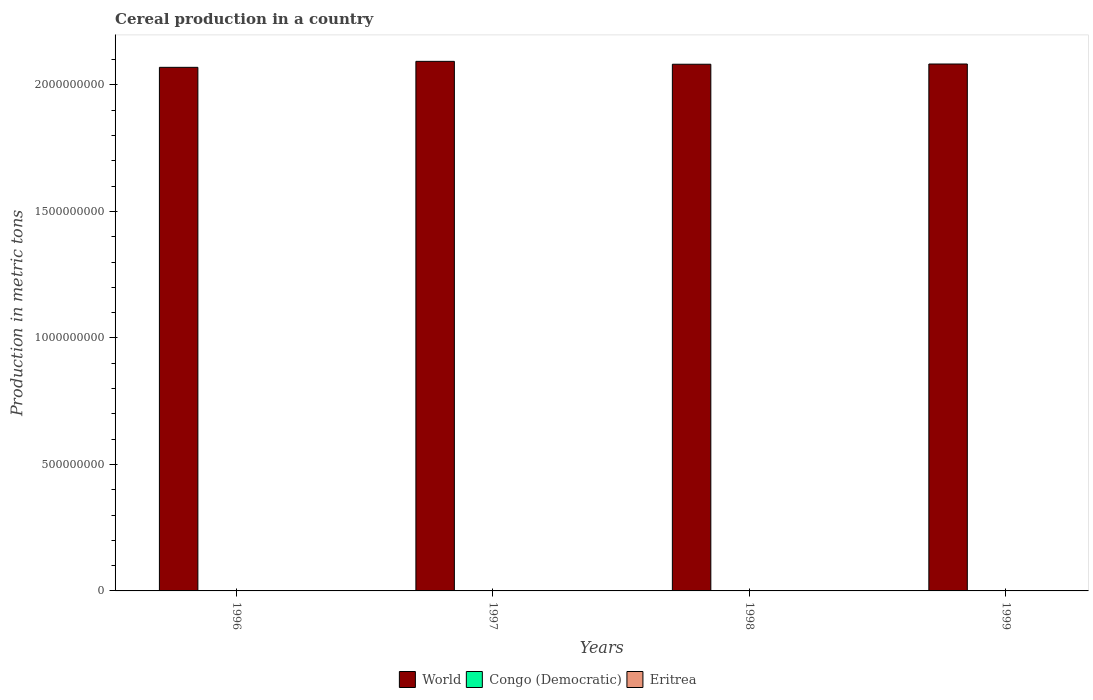How many different coloured bars are there?
Provide a succinct answer. 3. In how many cases, is the number of bars for a given year not equal to the number of legend labels?
Give a very brief answer. 0. What is the total cereal production in World in 1999?
Provide a succinct answer. 2.08e+09. Across all years, what is the maximum total cereal production in Eritrea?
Your answer should be compact. 4.58e+05. Across all years, what is the minimum total cereal production in Eritrea?
Provide a succinct answer. 8.54e+04. In which year was the total cereal production in World maximum?
Offer a very short reply. 1997. In which year was the total cereal production in World minimum?
Provide a short and direct response. 1996. What is the total total cereal production in Eritrea in the graph?
Provide a succinct answer. 9.61e+05. What is the difference between the total cereal production in Eritrea in 1996 and that in 1999?
Your answer should be compact. -2.33e+05. What is the difference between the total cereal production in Congo (Democratic) in 1998 and the total cereal production in World in 1999?
Offer a very short reply. -2.08e+09. What is the average total cereal production in World per year?
Make the answer very short. 2.08e+09. In the year 1997, what is the difference between the total cereal production in Eritrea and total cereal production in World?
Provide a short and direct response. -2.09e+09. What is the ratio of the total cereal production in World in 1997 to that in 1998?
Your response must be concise. 1.01. Is the total cereal production in World in 1996 less than that in 1998?
Your answer should be compact. Yes. Is the difference between the total cereal production in Eritrea in 1997 and 1999 greater than the difference between the total cereal production in World in 1997 and 1999?
Your response must be concise. No. What is the difference between the highest and the second highest total cereal production in Eritrea?
Offer a very short reply. 1.39e+05. What is the difference between the highest and the lowest total cereal production in Congo (Democratic)?
Keep it short and to the point. 8.96e+04. In how many years, is the total cereal production in Congo (Democratic) greater than the average total cereal production in Congo (Democratic) taken over all years?
Keep it short and to the point. 2. What does the 2nd bar from the left in 1999 represents?
Keep it short and to the point. Congo (Democratic). What does the 2nd bar from the right in 1996 represents?
Your answer should be compact. Congo (Democratic). Are all the bars in the graph horizontal?
Keep it short and to the point. No. How many years are there in the graph?
Ensure brevity in your answer.  4. Are the values on the major ticks of Y-axis written in scientific E-notation?
Your response must be concise. No. How many legend labels are there?
Provide a succinct answer. 3. What is the title of the graph?
Make the answer very short. Cereal production in a country. Does "Azerbaijan" appear as one of the legend labels in the graph?
Offer a terse response. No. What is the label or title of the X-axis?
Make the answer very short. Years. What is the label or title of the Y-axis?
Offer a very short reply. Production in metric tons. What is the Production in metric tons of World in 1996?
Offer a very short reply. 2.07e+09. What is the Production in metric tons in Congo (Democratic) in 1996?
Offer a terse response. 1.56e+06. What is the Production in metric tons of Eritrea in 1996?
Offer a terse response. 8.54e+04. What is the Production in metric tons of World in 1997?
Make the answer very short. 2.09e+09. What is the Production in metric tons of Congo (Democratic) in 1997?
Give a very brief answer. 1.53e+06. What is the Production in metric tons of Eritrea in 1997?
Your answer should be compact. 9.94e+04. What is the Production in metric tons of World in 1998?
Offer a terse response. 2.08e+09. What is the Production in metric tons in Congo (Democratic) in 1998?
Offer a very short reply. 1.62e+06. What is the Production in metric tons of Eritrea in 1998?
Ensure brevity in your answer.  4.58e+05. What is the Production in metric tons of World in 1999?
Ensure brevity in your answer.  2.08e+09. What is the Production in metric tons in Congo (Democratic) in 1999?
Make the answer very short. 1.59e+06. What is the Production in metric tons in Eritrea in 1999?
Your answer should be compact. 3.19e+05. Across all years, what is the maximum Production in metric tons of World?
Give a very brief answer. 2.09e+09. Across all years, what is the maximum Production in metric tons in Congo (Democratic)?
Provide a short and direct response. 1.62e+06. Across all years, what is the maximum Production in metric tons of Eritrea?
Provide a succinct answer. 4.58e+05. Across all years, what is the minimum Production in metric tons in World?
Provide a short and direct response. 2.07e+09. Across all years, what is the minimum Production in metric tons of Congo (Democratic)?
Make the answer very short. 1.53e+06. Across all years, what is the minimum Production in metric tons of Eritrea?
Your answer should be compact. 8.54e+04. What is the total Production in metric tons of World in the graph?
Offer a very short reply. 8.33e+09. What is the total Production in metric tons of Congo (Democratic) in the graph?
Your response must be concise. 6.30e+06. What is the total Production in metric tons in Eritrea in the graph?
Provide a short and direct response. 9.61e+05. What is the difference between the Production in metric tons of World in 1996 and that in 1997?
Offer a terse response. -2.37e+07. What is the difference between the Production in metric tons in Congo (Democratic) in 1996 and that in 1997?
Make the answer very short. 2.49e+04. What is the difference between the Production in metric tons in Eritrea in 1996 and that in 1997?
Your response must be concise. -1.40e+04. What is the difference between the Production in metric tons in World in 1996 and that in 1998?
Keep it short and to the point. -1.22e+07. What is the difference between the Production in metric tons in Congo (Democratic) in 1996 and that in 1998?
Provide a short and direct response. -6.46e+04. What is the difference between the Production in metric tons of Eritrea in 1996 and that in 1998?
Your response must be concise. -3.72e+05. What is the difference between the Production in metric tons of World in 1996 and that in 1999?
Give a very brief answer. -1.32e+07. What is the difference between the Production in metric tons in Congo (Democratic) in 1996 and that in 1999?
Provide a short and direct response. -3.60e+04. What is the difference between the Production in metric tons of Eritrea in 1996 and that in 1999?
Your answer should be very brief. -2.33e+05. What is the difference between the Production in metric tons in World in 1997 and that in 1998?
Offer a terse response. 1.14e+07. What is the difference between the Production in metric tons in Congo (Democratic) in 1997 and that in 1998?
Provide a succinct answer. -8.96e+04. What is the difference between the Production in metric tons in Eritrea in 1997 and that in 1998?
Offer a terse response. -3.58e+05. What is the difference between the Production in metric tons in World in 1997 and that in 1999?
Offer a terse response. 1.05e+07. What is the difference between the Production in metric tons of Congo (Democratic) in 1997 and that in 1999?
Ensure brevity in your answer.  -6.10e+04. What is the difference between the Production in metric tons of Eritrea in 1997 and that in 1999?
Offer a terse response. -2.19e+05. What is the difference between the Production in metric tons of World in 1998 and that in 1999?
Your answer should be compact. -9.28e+05. What is the difference between the Production in metric tons in Congo (Democratic) in 1998 and that in 1999?
Offer a very short reply. 2.86e+04. What is the difference between the Production in metric tons in Eritrea in 1998 and that in 1999?
Your answer should be very brief. 1.39e+05. What is the difference between the Production in metric tons in World in 1996 and the Production in metric tons in Congo (Democratic) in 1997?
Provide a succinct answer. 2.07e+09. What is the difference between the Production in metric tons in World in 1996 and the Production in metric tons in Eritrea in 1997?
Offer a terse response. 2.07e+09. What is the difference between the Production in metric tons of Congo (Democratic) in 1996 and the Production in metric tons of Eritrea in 1997?
Offer a terse response. 1.46e+06. What is the difference between the Production in metric tons in World in 1996 and the Production in metric tons in Congo (Democratic) in 1998?
Provide a succinct answer. 2.07e+09. What is the difference between the Production in metric tons of World in 1996 and the Production in metric tons of Eritrea in 1998?
Ensure brevity in your answer.  2.07e+09. What is the difference between the Production in metric tons of Congo (Democratic) in 1996 and the Production in metric tons of Eritrea in 1998?
Provide a succinct answer. 1.10e+06. What is the difference between the Production in metric tons of World in 1996 and the Production in metric tons of Congo (Democratic) in 1999?
Keep it short and to the point. 2.07e+09. What is the difference between the Production in metric tons of World in 1996 and the Production in metric tons of Eritrea in 1999?
Your answer should be very brief. 2.07e+09. What is the difference between the Production in metric tons of Congo (Democratic) in 1996 and the Production in metric tons of Eritrea in 1999?
Your response must be concise. 1.24e+06. What is the difference between the Production in metric tons in World in 1997 and the Production in metric tons in Congo (Democratic) in 1998?
Your answer should be compact. 2.09e+09. What is the difference between the Production in metric tons in World in 1997 and the Production in metric tons in Eritrea in 1998?
Your response must be concise. 2.09e+09. What is the difference between the Production in metric tons of Congo (Democratic) in 1997 and the Production in metric tons of Eritrea in 1998?
Keep it short and to the point. 1.07e+06. What is the difference between the Production in metric tons of World in 1997 and the Production in metric tons of Congo (Democratic) in 1999?
Provide a succinct answer. 2.09e+09. What is the difference between the Production in metric tons in World in 1997 and the Production in metric tons in Eritrea in 1999?
Your answer should be very brief. 2.09e+09. What is the difference between the Production in metric tons in Congo (Democratic) in 1997 and the Production in metric tons in Eritrea in 1999?
Provide a succinct answer. 1.21e+06. What is the difference between the Production in metric tons of World in 1998 and the Production in metric tons of Congo (Democratic) in 1999?
Your answer should be very brief. 2.08e+09. What is the difference between the Production in metric tons of World in 1998 and the Production in metric tons of Eritrea in 1999?
Give a very brief answer. 2.08e+09. What is the difference between the Production in metric tons in Congo (Democratic) in 1998 and the Production in metric tons in Eritrea in 1999?
Give a very brief answer. 1.30e+06. What is the average Production in metric tons of World per year?
Give a very brief answer. 2.08e+09. What is the average Production in metric tons in Congo (Democratic) per year?
Your response must be concise. 1.58e+06. What is the average Production in metric tons in Eritrea per year?
Offer a terse response. 2.40e+05. In the year 1996, what is the difference between the Production in metric tons of World and Production in metric tons of Congo (Democratic)?
Provide a short and direct response. 2.07e+09. In the year 1996, what is the difference between the Production in metric tons of World and Production in metric tons of Eritrea?
Give a very brief answer. 2.07e+09. In the year 1996, what is the difference between the Production in metric tons in Congo (Democratic) and Production in metric tons in Eritrea?
Provide a short and direct response. 1.47e+06. In the year 1997, what is the difference between the Production in metric tons of World and Production in metric tons of Congo (Democratic)?
Ensure brevity in your answer.  2.09e+09. In the year 1997, what is the difference between the Production in metric tons of World and Production in metric tons of Eritrea?
Offer a very short reply. 2.09e+09. In the year 1997, what is the difference between the Production in metric tons in Congo (Democratic) and Production in metric tons in Eritrea?
Give a very brief answer. 1.43e+06. In the year 1998, what is the difference between the Production in metric tons of World and Production in metric tons of Congo (Democratic)?
Offer a very short reply. 2.08e+09. In the year 1998, what is the difference between the Production in metric tons of World and Production in metric tons of Eritrea?
Ensure brevity in your answer.  2.08e+09. In the year 1998, what is the difference between the Production in metric tons of Congo (Democratic) and Production in metric tons of Eritrea?
Provide a succinct answer. 1.16e+06. In the year 1999, what is the difference between the Production in metric tons of World and Production in metric tons of Congo (Democratic)?
Give a very brief answer. 2.08e+09. In the year 1999, what is the difference between the Production in metric tons of World and Production in metric tons of Eritrea?
Keep it short and to the point. 2.08e+09. In the year 1999, what is the difference between the Production in metric tons of Congo (Democratic) and Production in metric tons of Eritrea?
Provide a succinct answer. 1.27e+06. What is the ratio of the Production in metric tons in World in 1996 to that in 1997?
Your answer should be very brief. 0.99. What is the ratio of the Production in metric tons of Congo (Democratic) in 1996 to that in 1997?
Your answer should be compact. 1.02. What is the ratio of the Production in metric tons in Eritrea in 1996 to that in 1997?
Your response must be concise. 0.86. What is the ratio of the Production in metric tons of World in 1996 to that in 1998?
Your response must be concise. 0.99. What is the ratio of the Production in metric tons of Congo (Democratic) in 1996 to that in 1998?
Provide a short and direct response. 0.96. What is the ratio of the Production in metric tons in Eritrea in 1996 to that in 1998?
Ensure brevity in your answer.  0.19. What is the ratio of the Production in metric tons of World in 1996 to that in 1999?
Your response must be concise. 0.99. What is the ratio of the Production in metric tons in Congo (Democratic) in 1996 to that in 1999?
Give a very brief answer. 0.98. What is the ratio of the Production in metric tons of Eritrea in 1996 to that in 1999?
Ensure brevity in your answer.  0.27. What is the ratio of the Production in metric tons of World in 1997 to that in 1998?
Your response must be concise. 1.01. What is the ratio of the Production in metric tons of Congo (Democratic) in 1997 to that in 1998?
Offer a very short reply. 0.94. What is the ratio of the Production in metric tons in Eritrea in 1997 to that in 1998?
Provide a short and direct response. 0.22. What is the ratio of the Production in metric tons in World in 1997 to that in 1999?
Your answer should be very brief. 1. What is the ratio of the Production in metric tons in Congo (Democratic) in 1997 to that in 1999?
Provide a short and direct response. 0.96. What is the ratio of the Production in metric tons of Eritrea in 1997 to that in 1999?
Your answer should be very brief. 0.31. What is the ratio of the Production in metric tons of Eritrea in 1998 to that in 1999?
Provide a succinct answer. 1.44. What is the difference between the highest and the second highest Production in metric tons in World?
Provide a succinct answer. 1.05e+07. What is the difference between the highest and the second highest Production in metric tons of Congo (Democratic)?
Provide a short and direct response. 2.86e+04. What is the difference between the highest and the second highest Production in metric tons in Eritrea?
Your answer should be very brief. 1.39e+05. What is the difference between the highest and the lowest Production in metric tons in World?
Offer a terse response. 2.37e+07. What is the difference between the highest and the lowest Production in metric tons of Congo (Democratic)?
Make the answer very short. 8.96e+04. What is the difference between the highest and the lowest Production in metric tons in Eritrea?
Offer a very short reply. 3.72e+05. 